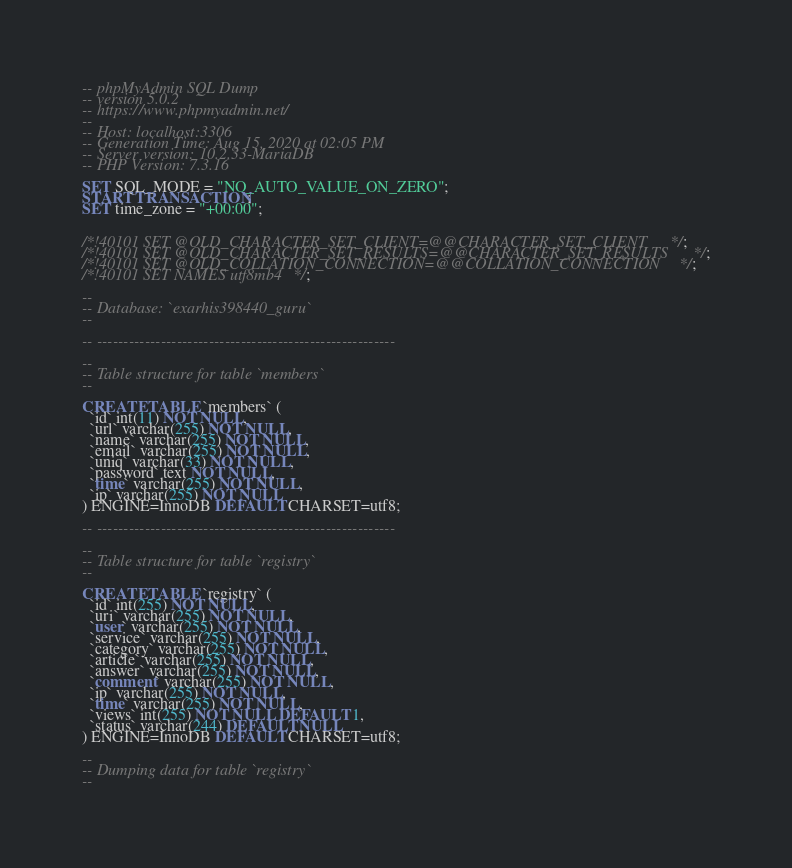Convert code to text. <code><loc_0><loc_0><loc_500><loc_500><_SQL_>-- phpMyAdmin SQL Dump
-- version 5.0.2
-- https://www.phpmyadmin.net/
--
-- Host: localhost:3306
-- Generation Time: Aug 15, 2020 at 02:05 PM
-- Server version: 10.2.33-MariaDB
-- PHP Version: 7.3.16

SET SQL_MODE = "NO_AUTO_VALUE_ON_ZERO";
START TRANSACTION;
SET time_zone = "+00:00";


/*!40101 SET @OLD_CHARACTER_SET_CLIENT=@@CHARACTER_SET_CLIENT */;
/*!40101 SET @OLD_CHARACTER_SET_RESULTS=@@CHARACTER_SET_RESULTS */;
/*!40101 SET @OLD_COLLATION_CONNECTION=@@COLLATION_CONNECTION */;
/*!40101 SET NAMES utf8mb4 */;

--
-- Database: `exarhis398440_guru`
--

-- --------------------------------------------------------

--
-- Table structure for table `members`
--

CREATE TABLE `members` (
  `id` int(11) NOT NULL,
  `url` varchar(255) NOT NULL,
  `name` varchar(255) NOT NULL,
  `email` varchar(255) NOT NULL,
  `uniq` varchar(33) NOT NULL,
  `password` text NOT NULL,
  `time` varchar(255) NOT NULL,
  `ip` varchar(255) NOT NULL
) ENGINE=InnoDB DEFAULT CHARSET=utf8;

-- --------------------------------------------------------

--
-- Table structure for table `registry`
--

CREATE TABLE `registry` (
  `id` int(255) NOT NULL,
  `uri` varchar(255) NOT NULL,
  `user` varchar(255) NOT NULL,
  `service` varchar(255) NOT NULL,
  `category` varchar(255) NOT NULL,
  `article` varchar(255) NOT NULL,
  `answer` varchar(255) NOT NULL,
  `comment` varchar(255) NOT NULL,
  `ip` varchar(255) NOT NULL,
  `time` varchar(255) NOT NULL,
  `views` int(255) NOT NULL DEFAULT 1,
  `status` varchar(244) DEFAULT NULL
) ENGINE=InnoDB DEFAULT CHARSET=utf8;

--
-- Dumping data for table `registry`
--
</code> 